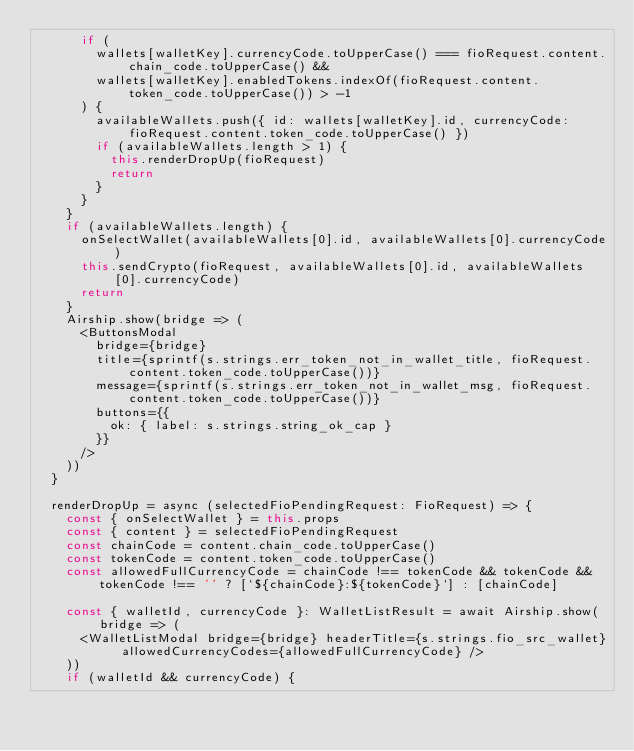<code> <loc_0><loc_0><loc_500><loc_500><_JavaScript_>      if (
        wallets[walletKey].currencyCode.toUpperCase() === fioRequest.content.chain_code.toUpperCase() &&
        wallets[walletKey].enabledTokens.indexOf(fioRequest.content.token_code.toUpperCase()) > -1
      ) {
        availableWallets.push({ id: wallets[walletKey].id, currencyCode: fioRequest.content.token_code.toUpperCase() })
        if (availableWallets.length > 1) {
          this.renderDropUp(fioRequest)
          return
        }
      }
    }
    if (availableWallets.length) {
      onSelectWallet(availableWallets[0].id, availableWallets[0].currencyCode)
      this.sendCrypto(fioRequest, availableWallets[0].id, availableWallets[0].currencyCode)
      return
    }
    Airship.show(bridge => (
      <ButtonsModal
        bridge={bridge}
        title={sprintf(s.strings.err_token_not_in_wallet_title, fioRequest.content.token_code.toUpperCase())}
        message={sprintf(s.strings.err_token_not_in_wallet_msg, fioRequest.content.token_code.toUpperCase())}
        buttons={{
          ok: { label: s.strings.string_ok_cap }
        }}
      />
    ))
  }

  renderDropUp = async (selectedFioPendingRequest: FioRequest) => {
    const { onSelectWallet } = this.props
    const { content } = selectedFioPendingRequest
    const chainCode = content.chain_code.toUpperCase()
    const tokenCode = content.token_code.toUpperCase()
    const allowedFullCurrencyCode = chainCode !== tokenCode && tokenCode && tokenCode !== '' ? [`${chainCode}:${tokenCode}`] : [chainCode]

    const { walletId, currencyCode }: WalletListResult = await Airship.show(bridge => (
      <WalletListModal bridge={bridge} headerTitle={s.strings.fio_src_wallet} allowedCurrencyCodes={allowedFullCurrencyCode} />
    ))
    if (walletId && currencyCode) {</code> 